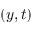Convert formula to latex. <formula><loc_0><loc_0><loc_500><loc_500>( y , t )</formula> 